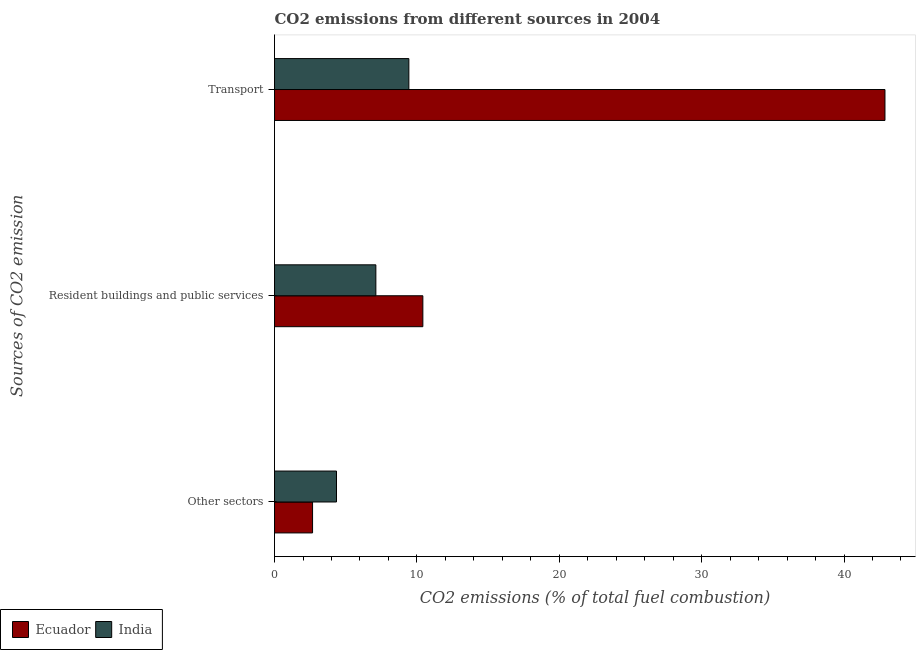Are the number of bars on each tick of the Y-axis equal?
Ensure brevity in your answer.  Yes. What is the label of the 1st group of bars from the top?
Offer a very short reply. Transport. What is the percentage of co2 emissions from transport in Ecuador?
Ensure brevity in your answer.  42.88. Across all countries, what is the maximum percentage of co2 emissions from resident buildings and public services?
Your answer should be very brief. 10.42. Across all countries, what is the minimum percentage of co2 emissions from other sectors?
Your response must be concise. 2.67. In which country was the percentage of co2 emissions from resident buildings and public services maximum?
Make the answer very short. Ecuador. In which country was the percentage of co2 emissions from resident buildings and public services minimum?
Offer a very short reply. India. What is the total percentage of co2 emissions from transport in the graph?
Make the answer very short. 52.31. What is the difference between the percentage of co2 emissions from transport in India and that in Ecuador?
Provide a succinct answer. -33.44. What is the difference between the percentage of co2 emissions from other sectors in India and the percentage of co2 emissions from resident buildings and public services in Ecuador?
Make the answer very short. -6.07. What is the average percentage of co2 emissions from transport per country?
Make the answer very short. 26.16. What is the difference between the percentage of co2 emissions from other sectors and percentage of co2 emissions from transport in Ecuador?
Offer a very short reply. -40.2. What is the ratio of the percentage of co2 emissions from other sectors in Ecuador to that in India?
Provide a succinct answer. 0.61. Is the percentage of co2 emissions from transport in Ecuador less than that in India?
Offer a terse response. No. What is the difference between the highest and the second highest percentage of co2 emissions from resident buildings and public services?
Keep it short and to the point. 3.3. What is the difference between the highest and the lowest percentage of co2 emissions from resident buildings and public services?
Ensure brevity in your answer.  3.3. In how many countries, is the percentage of co2 emissions from transport greater than the average percentage of co2 emissions from transport taken over all countries?
Your response must be concise. 1. Is the sum of the percentage of co2 emissions from transport in Ecuador and India greater than the maximum percentage of co2 emissions from resident buildings and public services across all countries?
Make the answer very short. Yes. What does the 2nd bar from the bottom in Transport represents?
Offer a terse response. India. Is it the case that in every country, the sum of the percentage of co2 emissions from other sectors and percentage of co2 emissions from resident buildings and public services is greater than the percentage of co2 emissions from transport?
Your response must be concise. No. How many bars are there?
Provide a succinct answer. 6. How many countries are there in the graph?
Provide a short and direct response. 2. What is the difference between two consecutive major ticks on the X-axis?
Your answer should be compact. 10. Are the values on the major ticks of X-axis written in scientific E-notation?
Offer a very short reply. No. How many legend labels are there?
Offer a very short reply. 2. How are the legend labels stacked?
Ensure brevity in your answer.  Horizontal. What is the title of the graph?
Your response must be concise. CO2 emissions from different sources in 2004. What is the label or title of the X-axis?
Your response must be concise. CO2 emissions (% of total fuel combustion). What is the label or title of the Y-axis?
Make the answer very short. Sources of CO2 emission. What is the CO2 emissions (% of total fuel combustion) in Ecuador in Other sectors?
Your response must be concise. 2.67. What is the CO2 emissions (% of total fuel combustion) in India in Other sectors?
Provide a short and direct response. 4.35. What is the CO2 emissions (% of total fuel combustion) of Ecuador in Resident buildings and public services?
Provide a succinct answer. 10.42. What is the CO2 emissions (% of total fuel combustion) in India in Resident buildings and public services?
Ensure brevity in your answer.  7.12. What is the CO2 emissions (% of total fuel combustion) in Ecuador in Transport?
Give a very brief answer. 42.88. What is the CO2 emissions (% of total fuel combustion) in India in Transport?
Your answer should be very brief. 9.43. Across all Sources of CO2 emission, what is the maximum CO2 emissions (% of total fuel combustion) in Ecuador?
Provide a succinct answer. 42.88. Across all Sources of CO2 emission, what is the maximum CO2 emissions (% of total fuel combustion) of India?
Make the answer very short. 9.43. Across all Sources of CO2 emission, what is the minimum CO2 emissions (% of total fuel combustion) of Ecuador?
Your answer should be compact. 2.67. Across all Sources of CO2 emission, what is the minimum CO2 emissions (% of total fuel combustion) in India?
Give a very brief answer. 4.35. What is the total CO2 emissions (% of total fuel combustion) of Ecuador in the graph?
Provide a succinct answer. 55.97. What is the total CO2 emissions (% of total fuel combustion) of India in the graph?
Your response must be concise. 20.9. What is the difference between the CO2 emissions (% of total fuel combustion) in Ecuador in Other sectors and that in Resident buildings and public services?
Your answer should be very brief. -7.75. What is the difference between the CO2 emissions (% of total fuel combustion) of India in Other sectors and that in Resident buildings and public services?
Your answer should be very brief. -2.77. What is the difference between the CO2 emissions (% of total fuel combustion) of Ecuador in Other sectors and that in Transport?
Make the answer very short. -40.2. What is the difference between the CO2 emissions (% of total fuel combustion) of India in Other sectors and that in Transport?
Provide a succinct answer. -5.08. What is the difference between the CO2 emissions (% of total fuel combustion) of Ecuador in Resident buildings and public services and that in Transport?
Your answer should be compact. -32.46. What is the difference between the CO2 emissions (% of total fuel combustion) in India in Resident buildings and public services and that in Transport?
Offer a terse response. -2.32. What is the difference between the CO2 emissions (% of total fuel combustion) in Ecuador in Other sectors and the CO2 emissions (% of total fuel combustion) in India in Resident buildings and public services?
Provide a succinct answer. -4.45. What is the difference between the CO2 emissions (% of total fuel combustion) in Ecuador in Other sectors and the CO2 emissions (% of total fuel combustion) in India in Transport?
Give a very brief answer. -6.76. What is the difference between the CO2 emissions (% of total fuel combustion) in Ecuador in Resident buildings and public services and the CO2 emissions (% of total fuel combustion) in India in Transport?
Make the answer very short. 0.98. What is the average CO2 emissions (% of total fuel combustion) in Ecuador per Sources of CO2 emission?
Your answer should be compact. 18.66. What is the average CO2 emissions (% of total fuel combustion) in India per Sources of CO2 emission?
Your response must be concise. 6.97. What is the difference between the CO2 emissions (% of total fuel combustion) of Ecuador and CO2 emissions (% of total fuel combustion) of India in Other sectors?
Your answer should be compact. -1.68. What is the difference between the CO2 emissions (% of total fuel combustion) in Ecuador and CO2 emissions (% of total fuel combustion) in India in Resident buildings and public services?
Your answer should be very brief. 3.3. What is the difference between the CO2 emissions (% of total fuel combustion) in Ecuador and CO2 emissions (% of total fuel combustion) in India in Transport?
Provide a succinct answer. 33.44. What is the ratio of the CO2 emissions (% of total fuel combustion) in Ecuador in Other sectors to that in Resident buildings and public services?
Ensure brevity in your answer.  0.26. What is the ratio of the CO2 emissions (% of total fuel combustion) of India in Other sectors to that in Resident buildings and public services?
Ensure brevity in your answer.  0.61. What is the ratio of the CO2 emissions (% of total fuel combustion) in Ecuador in Other sectors to that in Transport?
Give a very brief answer. 0.06. What is the ratio of the CO2 emissions (% of total fuel combustion) of India in Other sectors to that in Transport?
Ensure brevity in your answer.  0.46. What is the ratio of the CO2 emissions (% of total fuel combustion) in Ecuador in Resident buildings and public services to that in Transport?
Offer a very short reply. 0.24. What is the ratio of the CO2 emissions (% of total fuel combustion) of India in Resident buildings and public services to that in Transport?
Offer a terse response. 0.75. What is the difference between the highest and the second highest CO2 emissions (% of total fuel combustion) of Ecuador?
Offer a very short reply. 32.46. What is the difference between the highest and the second highest CO2 emissions (% of total fuel combustion) of India?
Offer a very short reply. 2.32. What is the difference between the highest and the lowest CO2 emissions (% of total fuel combustion) of Ecuador?
Provide a succinct answer. 40.2. What is the difference between the highest and the lowest CO2 emissions (% of total fuel combustion) in India?
Your answer should be compact. 5.08. 